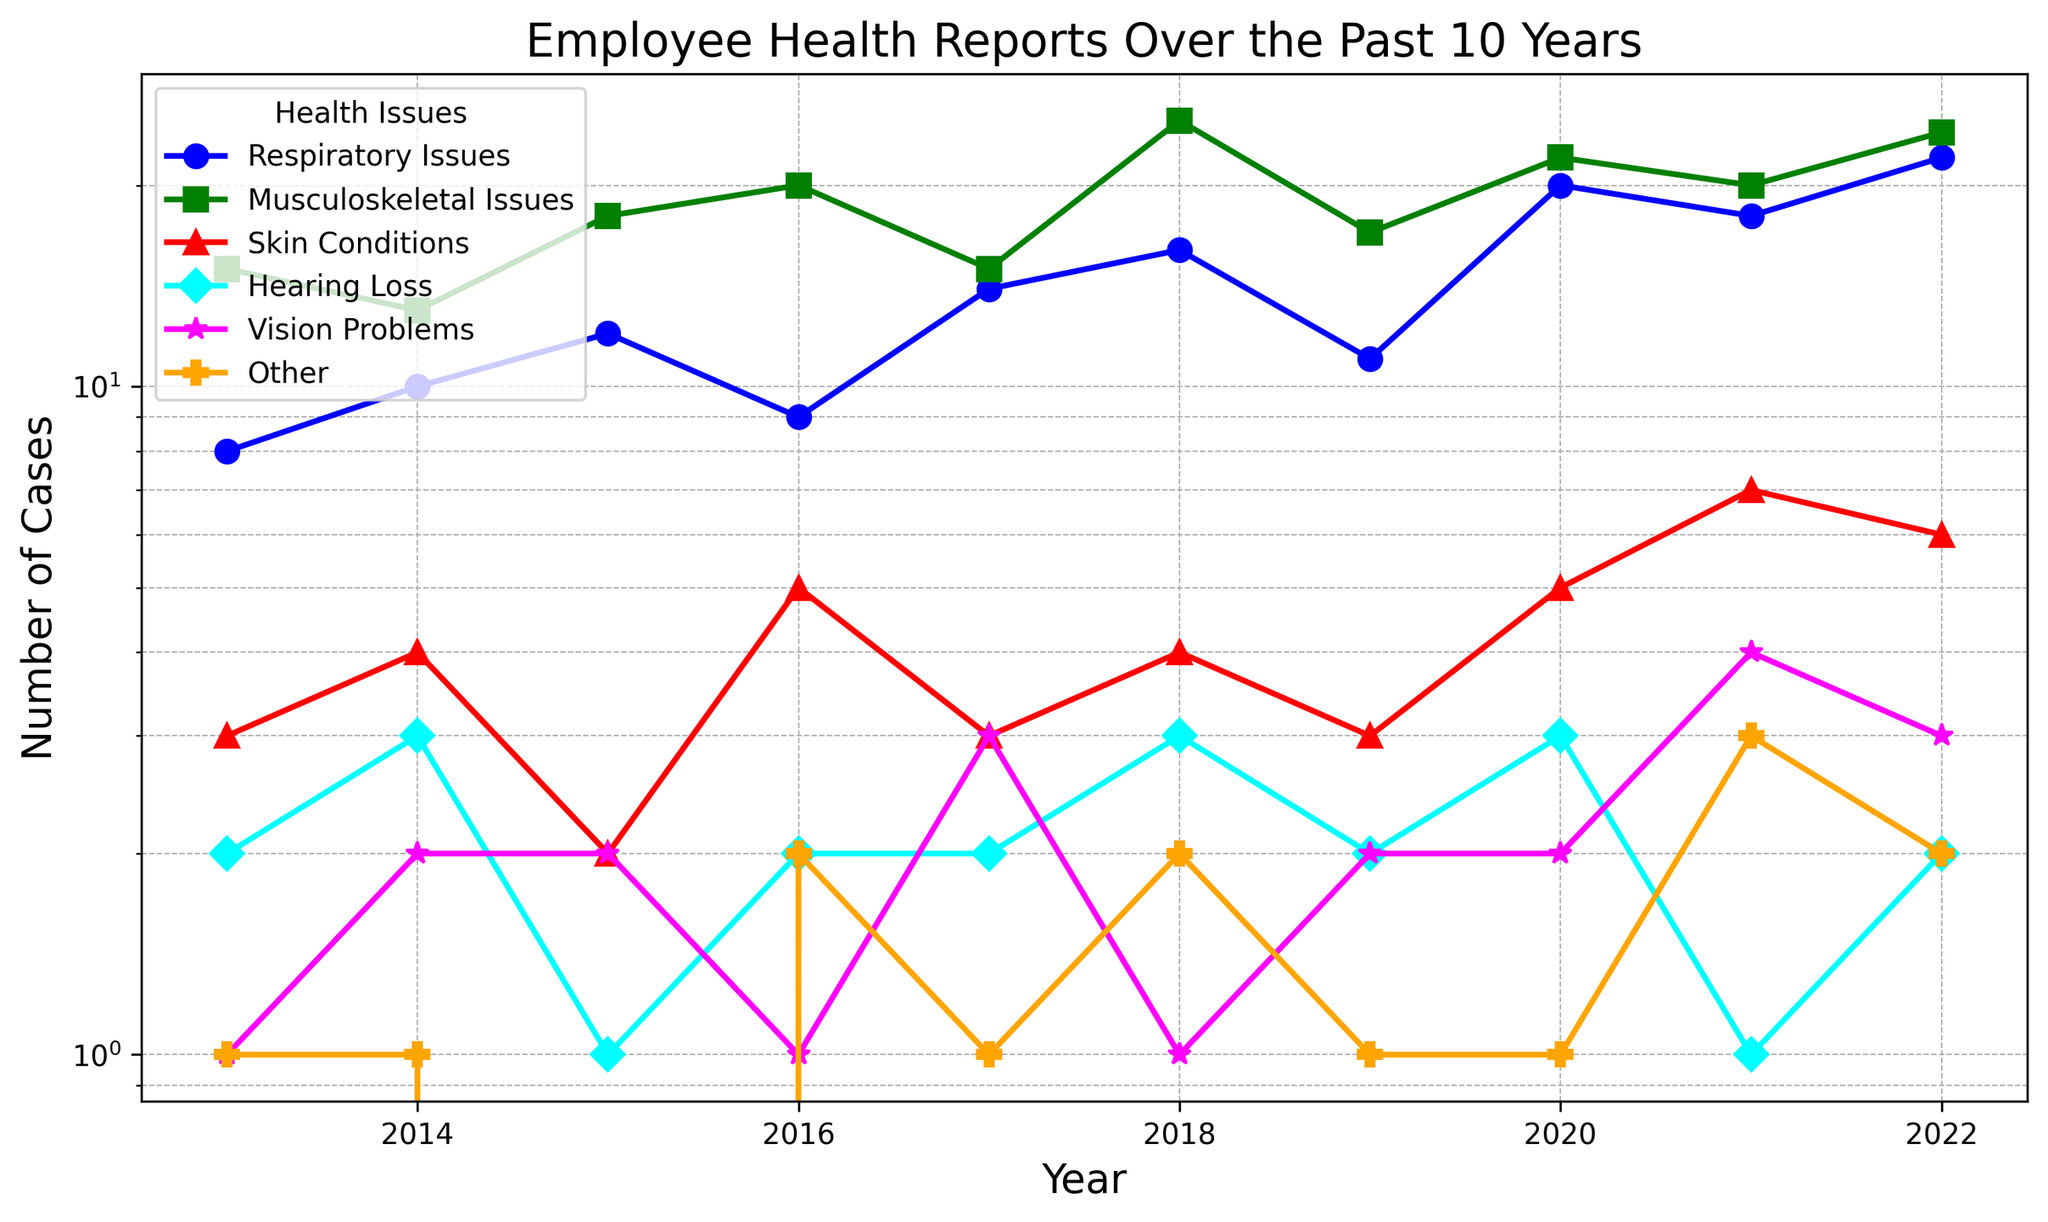What type of health issue saw the highest number of cases in 2022? The chart shows different health issues with different colors and markers. For 2022, find the highest point on the vertical scale and check which health issue it corresponds to.
Answer: Respiratory Issues How do the cases of Respiratory Issues in 2020 compare to those in 2016? Locate the points for Respiratory Issues in 2020 and 2016, respectively. The 2020 point is at 20 while the 2016 is at 9, thus 2020 has more cases.
Answer: Higher in 2020 What was the average number of Musculoskeletal Issues from 2013 to 2017? From the chart, find the Musculoskeletal Issues data points for 2013 to 2017: (15, 13, 18, 20, 15). Sum these values and divide by 5. Average = (15+13+18+20+15)/5 = 16.2
Answer: 16.2 Which health issue had the least variation in reported cases over the years? Visually inspect the lines’ fluctuations. The line with the least steepness and closest to a straight line indicates the least variation. Skin Conditions line appears most consistent.
Answer: Skin Conditions Were there more Vision Problems or Hearing Loss cases reported in 2021? Locate the data points for Vision Problems and Hearing Loss in 2021. Vision Problems = 4, Hearing Loss = 1. Thus, more Vision Problems.
Answer: Vision Problems What is the total number of Skin Conditions reported from 2019 to 2022? Check the data points for Skin Conditions for 2019-2022: (3, 5, 7, 6). Sum these values up: 3 + 5 + 7 + 6 = 21.
Answer: 21 Which year had the maximum number of other health issues combined reported? Sum the cases for each health issue per year and compare across years. 2020 has the highest with Respiratory: 20, Musculoe: 22, Skin: 5, Hearing: 3, Vision: 2, Other: 1. Total = 53.
Answer: 2020 Between 2018 and 2022, which health issue showed the largest increase in the number of cases? Identify the differences for each issue by subtracting 2018 values from 2022 values. Observe that Respiratory Issues increased from 16 to 22 showing an increase by 6.
Answer: Respiratory Issues How did Hearing Loss trend from 2013 to 2018? Trace the Hearing Loss line from 2013 to 2018. It starts at 2 in 2013, dips to 1 in 2015, then stabilizes at 2-3 levels, indicating fluctuating but overall stable trends.
Answer: Fluctuated slightly 